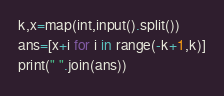<code> <loc_0><loc_0><loc_500><loc_500><_Python_>k,x=map(int,input().split())
ans=[x+i for i in range(-k+1,k)]
print(" ".join(ans))</code> 